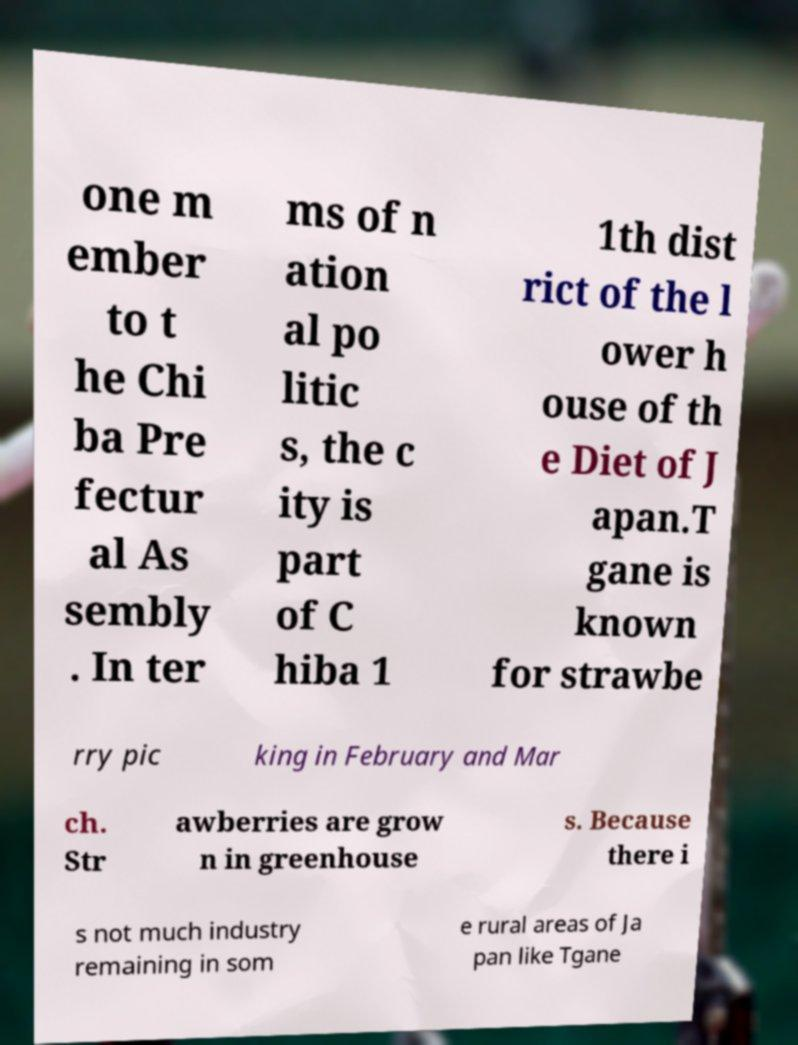There's text embedded in this image that I need extracted. Can you transcribe it verbatim? one m ember to t he Chi ba Pre fectur al As sembly . In ter ms of n ation al po litic s, the c ity is part of C hiba 1 1th dist rict of the l ower h ouse of th e Diet of J apan.T gane is known for strawbe rry pic king in February and Mar ch. Str awberries are grow n in greenhouse s. Because there i s not much industry remaining in som e rural areas of Ja pan like Tgane 